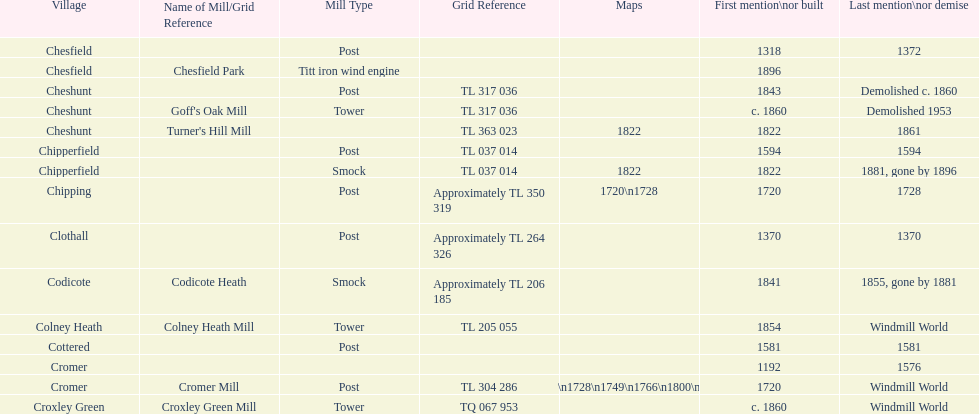How many locations have no photograph? 14. 